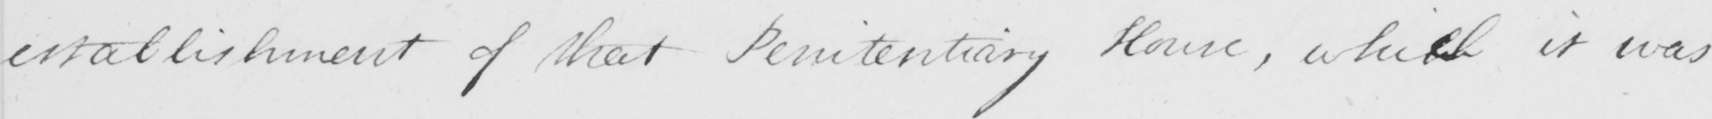Please provide the text content of this handwritten line. establishment of that Penitentiary House , whih ch it was 